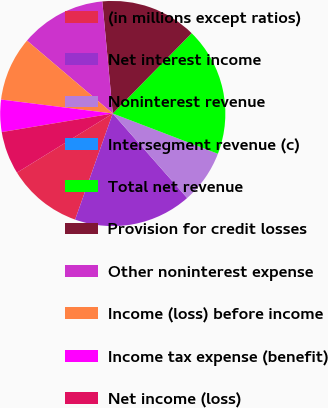<chart> <loc_0><loc_0><loc_500><loc_500><pie_chart><fcel>(in millions except ratios)<fcel>Net interest income<fcel>Noninterest revenue<fcel>Intersegment revenue (c)<fcel>Total net revenue<fcel>Provision for credit losses<fcel>Other noninterest expense<fcel>Income (loss) before income<fcel>Income tax expense (benefit)<fcel>Net income (loss)<nl><fcel>10.77%<fcel>16.92%<fcel>7.69%<fcel>0.0%<fcel>18.46%<fcel>13.84%<fcel>12.31%<fcel>9.23%<fcel>4.62%<fcel>6.16%<nl></chart> 